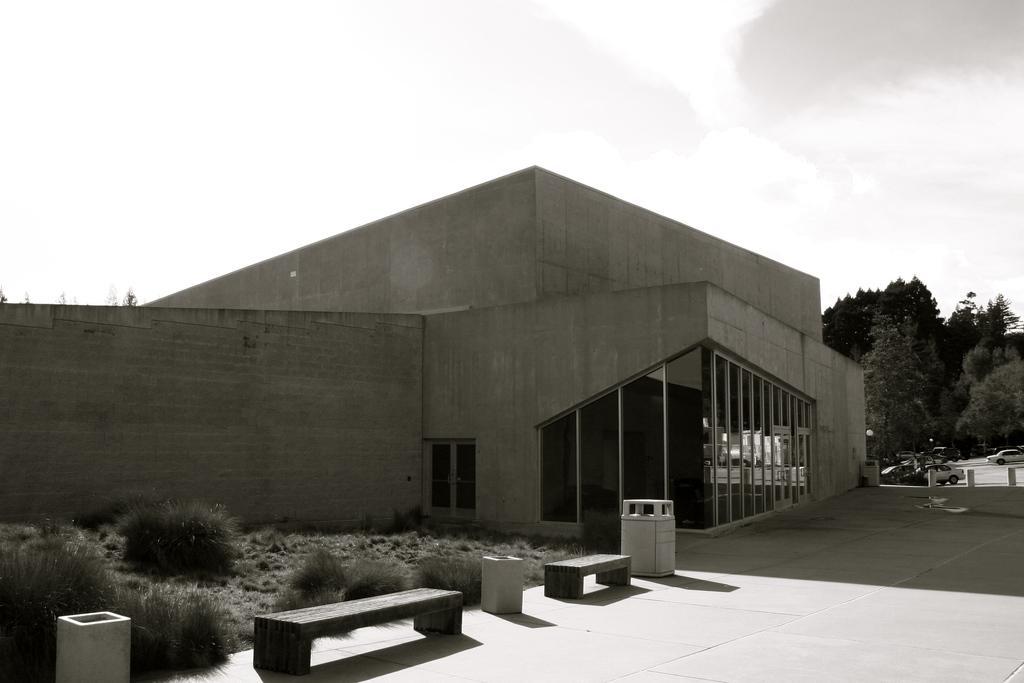How would you summarize this image in a sentence or two? In this image we can see a building with roof, windows and a door. We can also see some plants, benches, pole, trees, cars on the road and the sky which looks cloudy. 